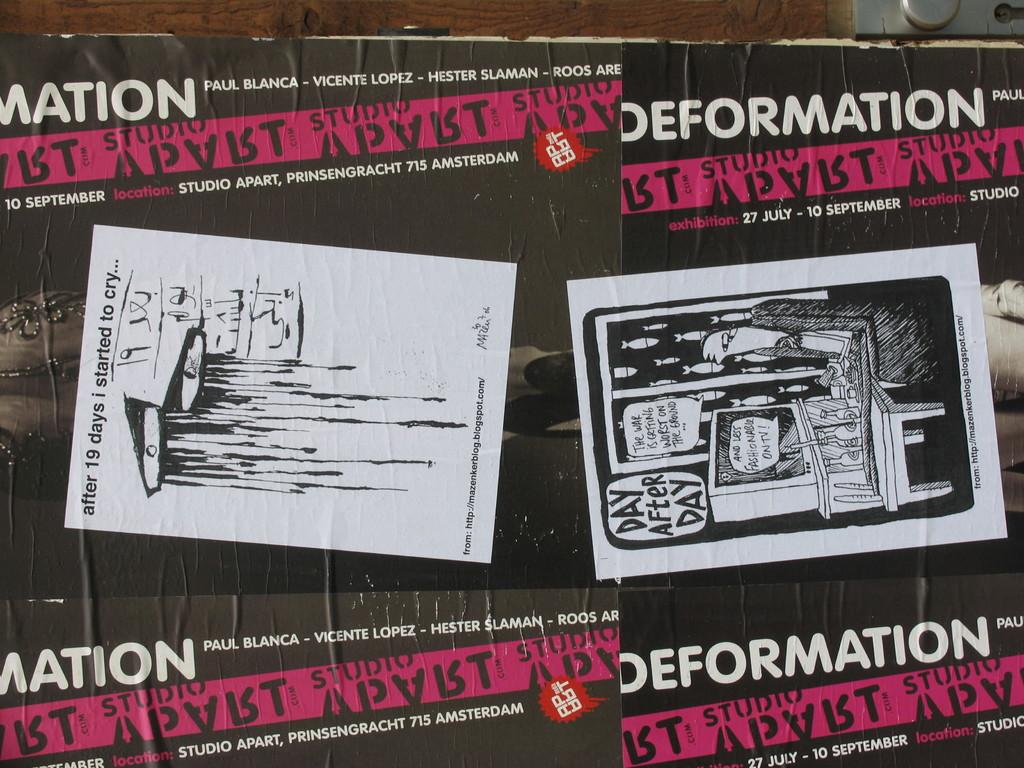<image>
Create a compact narrative representing the image presented. A poster board that titles Deformation with illustrations in the center 